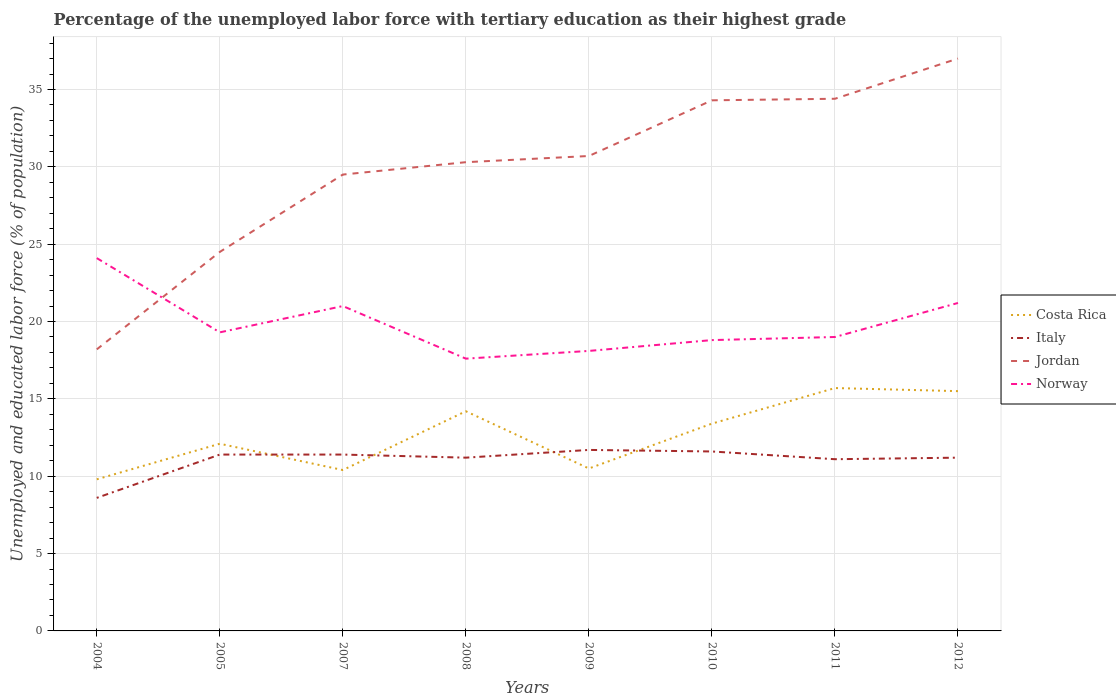Does the line corresponding to Costa Rica intersect with the line corresponding to Italy?
Your response must be concise. Yes. Is the number of lines equal to the number of legend labels?
Give a very brief answer. Yes. Across all years, what is the maximum percentage of the unemployed labor force with tertiary education in Italy?
Offer a very short reply. 8.6. In which year was the percentage of the unemployed labor force with tertiary education in Italy maximum?
Keep it short and to the point. 2004. What is the total percentage of the unemployed labor force with tertiary education in Jordan in the graph?
Your answer should be compact. -12.5. What is the difference between the highest and the second highest percentage of the unemployed labor force with tertiary education in Italy?
Offer a terse response. 3.1. What is the difference between the highest and the lowest percentage of the unemployed labor force with tertiary education in Jordan?
Keep it short and to the point. 5. How many lines are there?
Offer a terse response. 4. Where does the legend appear in the graph?
Your answer should be very brief. Center right. How are the legend labels stacked?
Make the answer very short. Vertical. What is the title of the graph?
Keep it short and to the point. Percentage of the unemployed labor force with tertiary education as their highest grade. What is the label or title of the X-axis?
Offer a very short reply. Years. What is the label or title of the Y-axis?
Provide a short and direct response. Unemployed and educated labor force (% of population). What is the Unemployed and educated labor force (% of population) of Costa Rica in 2004?
Your answer should be very brief. 9.8. What is the Unemployed and educated labor force (% of population) of Italy in 2004?
Keep it short and to the point. 8.6. What is the Unemployed and educated labor force (% of population) in Jordan in 2004?
Your answer should be very brief. 18.2. What is the Unemployed and educated labor force (% of population) of Norway in 2004?
Offer a terse response. 24.1. What is the Unemployed and educated labor force (% of population) in Costa Rica in 2005?
Offer a terse response. 12.1. What is the Unemployed and educated labor force (% of population) in Italy in 2005?
Keep it short and to the point. 11.4. What is the Unemployed and educated labor force (% of population) of Jordan in 2005?
Provide a succinct answer. 24.5. What is the Unemployed and educated labor force (% of population) in Norway in 2005?
Provide a short and direct response. 19.3. What is the Unemployed and educated labor force (% of population) of Costa Rica in 2007?
Ensure brevity in your answer.  10.4. What is the Unemployed and educated labor force (% of population) of Italy in 2007?
Your answer should be compact. 11.4. What is the Unemployed and educated labor force (% of population) in Jordan in 2007?
Your answer should be compact. 29.5. What is the Unemployed and educated labor force (% of population) in Costa Rica in 2008?
Provide a short and direct response. 14.2. What is the Unemployed and educated labor force (% of population) in Italy in 2008?
Your answer should be compact. 11.2. What is the Unemployed and educated labor force (% of population) in Jordan in 2008?
Ensure brevity in your answer.  30.3. What is the Unemployed and educated labor force (% of population) of Norway in 2008?
Your answer should be compact. 17.6. What is the Unemployed and educated labor force (% of population) of Costa Rica in 2009?
Keep it short and to the point. 10.5. What is the Unemployed and educated labor force (% of population) of Italy in 2009?
Make the answer very short. 11.7. What is the Unemployed and educated labor force (% of population) in Jordan in 2009?
Give a very brief answer. 30.7. What is the Unemployed and educated labor force (% of population) in Norway in 2009?
Your answer should be very brief. 18.1. What is the Unemployed and educated labor force (% of population) of Costa Rica in 2010?
Provide a succinct answer. 13.4. What is the Unemployed and educated labor force (% of population) in Italy in 2010?
Make the answer very short. 11.6. What is the Unemployed and educated labor force (% of population) in Jordan in 2010?
Provide a short and direct response. 34.3. What is the Unemployed and educated labor force (% of population) in Norway in 2010?
Provide a short and direct response. 18.8. What is the Unemployed and educated labor force (% of population) of Costa Rica in 2011?
Your answer should be very brief. 15.7. What is the Unemployed and educated labor force (% of population) in Italy in 2011?
Provide a short and direct response. 11.1. What is the Unemployed and educated labor force (% of population) of Jordan in 2011?
Your response must be concise. 34.4. What is the Unemployed and educated labor force (% of population) in Costa Rica in 2012?
Provide a short and direct response. 15.5. What is the Unemployed and educated labor force (% of population) in Italy in 2012?
Offer a terse response. 11.2. What is the Unemployed and educated labor force (% of population) of Norway in 2012?
Keep it short and to the point. 21.2. Across all years, what is the maximum Unemployed and educated labor force (% of population) of Costa Rica?
Provide a succinct answer. 15.7. Across all years, what is the maximum Unemployed and educated labor force (% of population) in Italy?
Give a very brief answer. 11.7. Across all years, what is the maximum Unemployed and educated labor force (% of population) of Jordan?
Give a very brief answer. 37. Across all years, what is the maximum Unemployed and educated labor force (% of population) in Norway?
Your answer should be very brief. 24.1. Across all years, what is the minimum Unemployed and educated labor force (% of population) of Costa Rica?
Provide a short and direct response. 9.8. Across all years, what is the minimum Unemployed and educated labor force (% of population) of Italy?
Provide a succinct answer. 8.6. Across all years, what is the minimum Unemployed and educated labor force (% of population) of Jordan?
Your response must be concise. 18.2. Across all years, what is the minimum Unemployed and educated labor force (% of population) of Norway?
Ensure brevity in your answer.  17.6. What is the total Unemployed and educated labor force (% of population) in Costa Rica in the graph?
Your response must be concise. 101.6. What is the total Unemployed and educated labor force (% of population) in Italy in the graph?
Make the answer very short. 88.2. What is the total Unemployed and educated labor force (% of population) in Jordan in the graph?
Give a very brief answer. 238.9. What is the total Unemployed and educated labor force (% of population) of Norway in the graph?
Keep it short and to the point. 159.1. What is the difference between the Unemployed and educated labor force (% of population) in Costa Rica in 2004 and that in 2005?
Give a very brief answer. -2.3. What is the difference between the Unemployed and educated labor force (% of population) of Jordan in 2004 and that in 2005?
Offer a very short reply. -6.3. What is the difference between the Unemployed and educated labor force (% of population) in Costa Rica in 2004 and that in 2007?
Ensure brevity in your answer.  -0.6. What is the difference between the Unemployed and educated labor force (% of population) of Italy in 2004 and that in 2007?
Your answer should be very brief. -2.8. What is the difference between the Unemployed and educated labor force (% of population) in Italy in 2004 and that in 2009?
Make the answer very short. -3.1. What is the difference between the Unemployed and educated labor force (% of population) in Jordan in 2004 and that in 2009?
Provide a succinct answer. -12.5. What is the difference between the Unemployed and educated labor force (% of population) of Norway in 2004 and that in 2009?
Offer a terse response. 6. What is the difference between the Unemployed and educated labor force (% of population) in Costa Rica in 2004 and that in 2010?
Keep it short and to the point. -3.6. What is the difference between the Unemployed and educated labor force (% of population) in Jordan in 2004 and that in 2010?
Give a very brief answer. -16.1. What is the difference between the Unemployed and educated labor force (% of population) in Italy in 2004 and that in 2011?
Ensure brevity in your answer.  -2.5. What is the difference between the Unemployed and educated labor force (% of population) in Jordan in 2004 and that in 2011?
Offer a terse response. -16.2. What is the difference between the Unemployed and educated labor force (% of population) in Norway in 2004 and that in 2011?
Your answer should be very brief. 5.1. What is the difference between the Unemployed and educated labor force (% of population) of Jordan in 2004 and that in 2012?
Offer a terse response. -18.8. What is the difference between the Unemployed and educated labor force (% of population) of Norway in 2004 and that in 2012?
Your answer should be compact. 2.9. What is the difference between the Unemployed and educated labor force (% of population) of Italy in 2005 and that in 2007?
Give a very brief answer. 0. What is the difference between the Unemployed and educated labor force (% of population) in Jordan in 2005 and that in 2007?
Your answer should be compact. -5. What is the difference between the Unemployed and educated labor force (% of population) in Norway in 2005 and that in 2007?
Ensure brevity in your answer.  -1.7. What is the difference between the Unemployed and educated labor force (% of population) of Italy in 2005 and that in 2008?
Keep it short and to the point. 0.2. What is the difference between the Unemployed and educated labor force (% of population) of Jordan in 2005 and that in 2008?
Keep it short and to the point. -5.8. What is the difference between the Unemployed and educated labor force (% of population) of Italy in 2005 and that in 2009?
Ensure brevity in your answer.  -0.3. What is the difference between the Unemployed and educated labor force (% of population) of Jordan in 2005 and that in 2009?
Your response must be concise. -6.2. What is the difference between the Unemployed and educated labor force (% of population) in Costa Rica in 2005 and that in 2010?
Keep it short and to the point. -1.3. What is the difference between the Unemployed and educated labor force (% of population) in Italy in 2005 and that in 2010?
Offer a terse response. -0.2. What is the difference between the Unemployed and educated labor force (% of population) of Jordan in 2005 and that in 2010?
Offer a very short reply. -9.8. What is the difference between the Unemployed and educated labor force (% of population) in Norway in 2005 and that in 2011?
Your answer should be very brief. 0.3. What is the difference between the Unemployed and educated labor force (% of population) in Italy in 2005 and that in 2012?
Your response must be concise. 0.2. What is the difference between the Unemployed and educated labor force (% of population) in Jordan in 2005 and that in 2012?
Your response must be concise. -12.5. What is the difference between the Unemployed and educated labor force (% of population) of Costa Rica in 2007 and that in 2008?
Ensure brevity in your answer.  -3.8. What is the difference between the Unemployed and educated labor force (% of population) in Italy in 2007 and that in 2009?
Ensure brevity in your answer.  -0.3. What is the difference between the Unemployed and educated labor force (% of population) in Jordan in 2007 and that in 2009?
Give a very brief answer. -1.2. What is the difference between the Unemployed and educated labor force (% of population) of Costa Rica in 2007 and that in 2010?
Provide a short and direct response. -3. What is the difference between the Unemployed and educated labor force (% of population) of Costa Rica in 2007 and that in 2011?
Keep it short and to the point. -5.3. What is the difference between the Unemployed and educated labor force (% of population) in Italy in 2007 and that in 2011?
Give a very brief answer. 0.3. What is the difference between the Unemployed and educated labor force (% of population) of Jordan in 2007 and that in 2011?
Your answer should be compact. -4.9. What is the difference between the Unemployed and educated labor force (% of population) in Italy in 2007 and that in 2012?
Provide a short and direct response. 0.2. What is the difference between the Unemployed and educated labor force (% of population) of Norway in 2007 and that in 2012?
Provide a succinct answer. -0.2. What is the difference between the Unemployed and educated labor force (% of population) of Costa Rica in 2008 and that in 2009?
Offer a terse response. 3.7. What is the difference between the Unemployed and educated labor force (% of population) of Norway in 2008 and that in 2009?
Provide a succinct answer. -0.5. What is the difference between the Unemployed and educated labor force (% of population) of Italy in 2008 and that in 2010?
Your response must be concise. -0.4. What is the difference between the Unemployed and educated labor force (% of population) in Norway in 2008 and that in 2010?
Give a very brief answer. -1.2. What is the difference between the Unemployed and educated labor force (% of population) in Jordan in 2008 and that in 2011?
Your answer should be compact. -4.1. What is the difference between the Unemployed and educated labor force (% of population) in Norway in 2008 and that in 2011?
Your answer should be very brief. -1.4. What is the difference between the Unemployed and educated labor force (% of population) of Costa Rica in 2008 and that in 2012?
Keep it short and to the point. -1.3. What is the difference between the Unemployed and educated labor force (% of population) in Italy in 2008 and that in 2012?
Your answer should be compact. 0. What is the difference between the Unemployed and educated labor force (% of population) in Jordan in 2008 and that in 2012?
Keep it short and to the point. -6.7. What is the difference between the Unemployed and educated labor force (% of population) of Norway in 2008 and that in 2012?
Offer a terse response. -3.6. What is the difference between the Unemployed and educated labor force (% of population) of Jordan in 2009 and that in 2010?
Offer a very short reply. -3.6. What is the difference between the Unemployed and educated labor force (% of population) in Italy in 2009 and that in 2011?
Keep it short and to the point. 0.6. What is the difference between the Unemployed and educated labor force (% of population) of Jordan in 2009 and that in 2011?
Give a very brief answer. -3.7. What is the difference between the Unemployed and educated labor force (% of population) of Italy in 2009 and that in 2012?
Offer a very short reply. 0.5. What is the difference between the Unemployed and educated labor force (% of population) in Jordan in 2010 and that in 2011?
Give a very brief answer. -0.1. What is the difference between the Unemployed and educated labor force (% of population) in Jordan in 2010 and that in 2012?
Make the answer very short. -2.7. What is the difference between the Unemployed and educated labor force (% of population) in Norway in 2010 and that in 2012?
Provide a succinct answer. -2.4. What is the difference between the Unemployed and educated labor force (% of population) of Costa Rica in 2011 and that in 2012?
Your response must be concise. 0.2. What is the difference between the Unemployed and educated labor force (% of population) of Italy in 2011 and that in 2012?
Ensure brevity in your answer.  -0.1. What is the difference between the Unemployed and educated labor force (% of population) in Costa Rica in 2004 and the Unemployed and educated labor force (% of population) in Italy in 2005?
Provide a succinct answer. -1.6. What is the difference between the Unemployed and educated labor force (% of population) of Costa Rica in 2004 and the Unemployed and educated labor force (% of population) of Jordan in 2005?
Your answer should be very brief. -14.7. What is the difference between the Unemployed and educated labor force (% of population) of Italy in 2004 and the Unemployed and educated labor force (% of population) of Jordan in 2005?
Your response must be concise. -15.9. What is the difference between the Unemployed and educated labor force (% of population) of Italy in 2004 and the Unemployed and educated labor force (% of population) of Norway in 2005?
Keep it short and to the point. -10.7. What is the difference between the Unemployed and educated labor force (% of population) of Costa Rica in 2004 and the Unemployed and educated labor force (% of population) of Italy in 2007?
Keep it short and to the point. -1.6. What is the difference between the Unemployed and educated labor force (% of population) in Costa Rica in 2004 and the Unemployed and educated labor force (% of population) in Jordan in 2007?
Give a very brief answer. -19.7. What is the difference between the Unemployed and educated labor force (% of population) in Italy in 2004 and the Unemployed and educated labor force (% of population) in Jordan in 2007?
Your answer should be compact. -20.9. What is the difference between the Unemployed and educated labor force (% of population) of Jordan in 2004 and the Unemployed and educated labor force (% of population) of Norway in 2007?
Your response must be concise. -2.8. What is the difference between the Unemployed and educated labor force (% of population) in Costa Rica in 2004 and the Unemployed and educated labor force (% of population) in Italy in 2008?
Give a very brief answer. -1.4. What is the difference between the Unemployed and educated labor force (% of population) in Costa Rica in 2004 and the Unemployed and educated labor force (% of population) in Jordan in 2008?
Give a very brief answer. -20.5. What is the difference between the Unemployed and educated labor force (% of population) in Costa Rica in 2004 and the Unemployed and educated labor force (% of population) in Norway in 2008?
Offer a terse response. -7.8. What is the difference between the Unemployed and educated labor force (% of population) of Italy in 2004 and the Unemployed and educated labor force (% of population) of Jordan in 2008?
Provide a succinct answer. -21.7. What is the difference between the Unemployed and educated labor force (% of population) in Costa Rica in 2004 and the Unemployed and educated labor force (% of population) in Italy in 2009?
Offer a very short reply. -1.9. What is the difference between the Unemployed and educated labor force (% of population) in Costa Rica in 2004 and the Unemployed and educated labor force (% of population) in Jordan in 2009?
Keep it short and to the point. -20.9. What is the difference between the Unemployed and educated labor force (% of population) in Costa Rica in 2004 and the Unemployed and educated labor force (% of population) in Norway in 2009?
Give a very brief answer. -8.3. What is the difference between the Unemployed and educated labor force (% of population) in Italy in 2004 and the Unemployed and educated labor force (% of population) in Jordan in 2009?
Provide a succinct answer. -22.1. What is the difference between the Unemployed and educated labor force (% of population) of Italy in 2004 and the Unemployed and educated labor force (% of population) of Norway in 2009?
Offer a terse response. -9.5. What is the difference between the Unemployed and educated labor force (% of population) in Costa Rica in 2004 and the Unemployed and educated labor force (% of population) in Italy in 2010?
Provide a short and direct response. -1.8. What is the difference between the Unemployed and educated labor force (% of population) in Costa Rica in 2004 and the Unemployed and educated labor force (% of population) in Jordan in 2010?
Ensure brevity in your answer.  -24.5. What is the difference between the Unemployed and educated labor force (% of population) in Costa Rica in 2004 and the Unemployed and educated labor force (% of population) in Norway in 2010?
Your answer should be very brief. -9. What is the difference between the Unemployed and educated labor force (% of population) in Italy in 2004 and the Unemployed and educated labor force (% of population) in Jordan in 2010?
Offer a very short reply. -25.7. What is the difference between the Unemployed and educated labor force (% of population) in Italy in 2004 and the Unemployed and educated labor force (% of population) in Norway in 2010?
Give a very brief answer. -10.2. What is the difference between the Unemployed and educated labor force (% of population) in Jordan in 2004 and the Unemployed and educated labor force (% of population) in Norway in 2010?
Give a very brief answer. -0.6. What is the difference between the Unemployed and educated labor force (% of population) in Costa Rica in 2004 and the Unemployed and educated labor force (% of population) in Jordan in 2011?
Offer a very short reply. -24.6. What is the difference between the Unemployed and educated labor force (% of population) in Italy in 2004 and the Unemployed and educated labor force (% of population) in Jordan in 2011?
Your answer should be compact. -25.8. What is the difference between the Unemployed and educated labor force (% of population) in Italy in 2004 and the Unemployed and educated labor force (% of population) in Norway in 2011?
Keep it short and to the point. -10.4. What is the difference between the Unemployed and educated labor force (% of population) in Costa Rica in 2004 and the Unemployed and educated labor force (% of population) in Italy in 2012?
Your response must be concise. -1.4. What is the difference between the Unemployed and educated labor force (% of population) of Costa Rica in 2004 and the Unemployed and educated labor force (% of population) of Jordan in 2012?
Keep it short and to the point. -27.2. What is the difference between the Unemployed and educated labor force (% of population) of Costa Rica in 2004 and the Unemployed and educated labor force (% of population) of Norway in 2012?
Your response must be concise. -11.4. What is the difference between the Unemployed and educated labor force (% of population) of Italy in 2004 and the Unemployed and educated labor force (% of population) of Jordan in 2012?
Provide a succinct answer. -28.4. What is the difference between the Unemployed and educated labor force (% of population) in Italy in 2004 and the Unemployed and educated labor force (% of population) in Norway in 2012?
Offer a very short reply. -12.6. What is the difference between the Unemployed and educated labor force (% of population) in Jordan in 2004 and the Unemployed and educated labor force (% of population) in Norway in 2012?
Offer a terse response. -3. What is the difference between the Unemployed and educated labor force (% of population) of Costa Rica in 2005 and the Unemployed and educated labor force (% of population) of Jordan in 2007?
Provide a succinct answer. -17.4. What is the difference between the Unemployed and educated labor force (% of population) in Italy in 2005 and the Unemployed and educated labor force (% of population) in Jordan in 2007?
Keep it short and to the point. -18.1. What is the difference between the Unemployed and educated labor force (% of population) of Italy in 2005 and the Unemployed and educated labor force (% of population) of Norway in 2007?
Provide a short and direct response. -9.6. What is the difference between the Unemployed and educated labor force (% of population) in Jordan in 2005 and the Unemployed and educated labor force (% of population) in Norway in 2007?
Offer a terse response. 3.5. What is the difference between the Unemployed and educated labor force (% of population) in Costa Rica in 2005 and the Unemployed and educated labor force (% of population) in Jordan in 2008?
Provide a succinct answer. -18.2. What is the difference between the Unemployed and educated labor force (% of population) of Costa Rica in 2005 and the Unemployed and educated labor force (% of population) of Norway in 2008?
Offer a terse response. -5.5. What is the difference between the Unemployed and educated labor force (% of population) of Italy in 2005 and the Unemployed and educated labor force (% of population) of Jordan in 2008?
Give a very brief answer. -18.9. What is the difference between the Unemployed and educated labor force (% of population) of Italy in 2005 and the Unemployed and educated labor force (% of population) of Norway in 2008?
Keep it short and to the point. -6.2. What is the difference between the Unemployed and educated labor force (% of population) in Costa Rica in 2005 and the Unemployed and educated labor force (% of population) in Jordan in 2009?
Your response must be concise. -18.6. What is the difference between the Unemployed and educated labor force (% of population) in Costa Rica in 2005 and the Unemployed and educated labor force (% of population) in Norway in 2009?
Make the answer very short. -6. What is the difference between the Unemployed and educated labor force (% of population) of Italy in 2005 and the Unemployed and educated labor force (% of population) of Jordan in 2009?
Provide a succinct answer. -19.3. What is the difference between the Unemployed and educated labor force (% of population) of Costa Rica in 2005 and the Unemployed and educated labor force (% of population) of Jordan in 2010?
Give a very brief answer. -22.2. What is the difference between the Unemployed and educated labor force (% of population) of Italy in 2005 and the Unemployed and educated labor force (% of population) of Jordan in 2010?
Keep it short and to the point. -22.9. What is the difference between the Unemployed and educated labor force (% of population) in Italy in 2005 and the Unemployed and educated labor force (% of population) in Norway in 2010?
Make the answer very short. -7.4. What is the difference between the Unemployed and educated labor force (% of population) of Jordan in 2005 and the Unemployed and educated labor force (% of population) of Norway in 2010?
Provide a succinct answer. 5.7. What is the difference between the Unemployed and educated labor force (% of population) in Costa Rica in 2005 and the Unemployed and educated labor force (% of population) in Italy in 2011?
Ensure brevity in your answer.  1. What is the difference between the Unemployed and educated labor force (% of population) of Costa Rica in 2005 and the Unemployed and educated labor force (% of population) of Jordan in 2011?
Give a very brief answer. -22.3. What is the difference between the Unemployed and educated labor force (% of population) in Costa Rica in 2005 and the Unemployed and educated labor force (% of population) in Norway in 2011?
Make the answer very short. -6.9. What is the difference between the Unemployed and educated labor force (% of population) in Italy in 2005 and the Unemployed and educated labor force (% of population) in Jordan in 2011?
Offer a very short reply. -23. What is the difference between the Unemployed and educated labor force (% of population) in Italy in 2005 and the Unemployed and educated labor force (% of population) in Norway in 2011?
Your response must be concise. -7.6. What is the difference between the Unemployed and educated labor force (% of population) in Costa Rica in 2005 and the Unemployed and educated labor force (% of population) in Italy in 2012?
Offer a terse response. 0.9. What is the difference between the Unemployed and educated labor force (% of population) in Costa Rica in 2005 and the Unemployed and educated labor force (% of population) in Jordan in 2012?
Your answer should be very brief. -24.9. What is the difference between the Unemployed and educated labor force (% of population) of Italy in 2005 and the Unemployed and educated labor force (% of population) of Jordan in 2012?
Your response must be concise. -25.6. What is the difference between the Unemployed and educated labor force (% of population) in Costa Rica in 2007 and the Unemployed and educated labor force (% of population) in Jordan in 2008?
Your response must be concise. -19.9. What is the difference between the Unemployed and educated labor force (% of population) of Costa Rica in 2007 and the Unemployed and educated labor force (% of population) of Norway in 2008?
Offer a terse response. -7.2. What is the difference between the Unemployed and educated labor force (% of population) of Italy in 2007 and the Unemployed and educated labor force (% of population) of Jordan in 2008?
Give a very brief answer. -18.9. What is the difference between the Unemployed and educated labor force (% of population) of Italy in 2007 and the Unemployed and educated labor force (% of population) of Norway in 2008?
Your answer should be compact. -6.2. What is the difference between the Unemployed and educated labor force (% of population) in Jordan in 2007 and the Unemployed and educated labor force (% of population) in Norway in 2008?
Keep it short and to the point. 11.9. What is the difference between the Unemployed and educated labor force (% of population) of Costa Rica in 2007 and the Unemployed and educated labor force (% of population) of Italy in 2009?
Offer a terse response. -1.3. What is the difference between the Unemployed and educated labor force (% of population) in Costa Rica in 2007 and the Unemployed and educated labor force (% of population) in Jordan in 2009?
Ensure brevity in your answer.  -20.3. What is the difference between the Unemployed and educated labor force (% of population) in Italy in 2007 and the Unemployed and educated labor force (% of population) in Jordan in 2009?
Keep it short and to the point. -19.3. What is the difference between the Unemployed and educated labor force (% of population) of Italy in 2007 and the Unemployed and educated labor force (% of population) of Norway in 2009?
Offer a very short reply. -6.7. What is the difference between the Unemployed and educated labor force (% of population) in Jordan in 2007 and the Unemployed and educated labor force (% of population) in Norway in 2009?
Offer a very short reply. 11.4. What is the difference between the Unemployed and educated labor force (% of population) in Costa Rica in 2007 and the Unemployed and educated labor force (% of population) in Italy in 2010?
Your answer should be compact. -1.2. What is the difference between the Unemployed and educated labor force (% of population) in Costa Rica in 2007 and the Unemployed and educated labor force (% of population) in Jordan in 2010?
Your answer should be very brief. -23.9. What is the difference between the Unemployed and educated labor force (% of population) in Italy in 2007 and the Unemployed and educated labor force (% of population) in Jordan in 2010?
Offer a very short reply. -22.9. What is the difference between the Unemployed and educated labor force (% of population) in Italy in 2007 and the Unemployed and educated labor force (% of population) in Norway in 2010?
Keep it short and to the point. -7.4. What is the difference between the Unemployed and educated labor force (% of population) in Jordan in 2007 and the Unemployed and educated labor force (% of population) in Norway in 2010?
Your answer should be very brief. 10.7. What is the difference between the Unemployed and educated labor force (% of population) in Costa Rica in 2007 and the Unemployed and educated labor force (% of population) in Italy in 2011?
Make the answer very short. -0.7. What is the difference between the Unemployed and educated labor force (% of population) of Costa Rica in 2007 and the Unemployed and educated labor force (% of population) of Norway in 2011?
Your answer should be very brief. -8.6. What is the difference between the Unemployed and educated labor force (% of population) of Jordan in 2007 and the Unemployed and educated labor force (% of population) of Norway in 2011?
Your answer should be very brief. 10.5. What is the difference between the Unemployed and educated labor force (% of population) of Costa Rica in 2007 and the Unemployed and educated labor force (% of population) of Italy in 2012?
Keep it short and to the point. -0.8. What is the difference between the Unemployed and educated labor force (% of population) of Costa Rica in 2007 and the Unemployed and educated labor force (% of population) of Jordan in 2012?
Offer a terse response. -26.6. What is the difference between the Unemployed and educated labor force (% of population) of Costa Rica in 2007 and the Unemployed and educated labor force (% of population) of Norway in 2012?
Keep it short and to the point. -10.8. What is the difference between the Unemployed and educated labor force (% of population) in Italy in 2007 and the Unemployed and educated labor force (% of population) in Jordan in 2012?
Make the answer very short. -25.6. What is the difference between the Unemployed and educated labor force (% of population) of Italy in 2007 and the Unemployed and educated labor force (% of population) of Norway in 2012?
Offer a terse response. -9.8. What is the difference between the Unemployed and educated labor force (% of population) of Jordan in 2007 and the Unemployed and educated labor force (% of population) of Norway in 2012?
Keep it short and to the point. 8.3. What is the difference between the Unemployed and educated labor force (% of population) in Costa Rica in 2008 and the Unemployed and educated labor force (% of population) in Jordan in 2009?
Your response must be concise. -16.5. What is the difference between the Unemployed and educated labor force (% of population) of Costa Rica in 2008 and the Unemployed and educated labor force (% of population) of Norway in 2009?
Provide a succinct answer. -3.9. What is the difference between the Unemployed and educated labor force (% of population) of Italy in 2008 and the Unemployed and educated labor force (% of population) of Jordan in 2009?
Your answer should be very brief. -19.5. What is the difference between the Unemployed and educated labor force (% of population) in Costa Rica in 2008 and the Unemployed and educated labor force (% of population) in Italy in 2010?
Provide a succinct answer. 2.6. What is the difference between the Unemployed and educated labor force (% of population) in Costa Rica in 2008 and the Unemployed and educated labor force (% of population) in Jordan in 2010?
Keep it short and to the point. -20.1. What is the difference between the Unemployed and educated labor force (% of population) of Italy in 2008 and the Unemployed and educated labor force (% of population) of Jordan in 2010?
Your response must be concise. -23.1. What is the difference between the Unemployed and educated labor force (% of population) of Italy in 2008 and the Unemployed and educated labor force (% of population) of Norway in 2010?
Provide a succinct answer. -7.6. What is the difference between the Unemployed and educated labor force (% of population) of Jordan in 2008 and the Unemployed and educated labor force (% of population) of Norway in 2010?
Your answer should be compact. 11.5. What is the difference between the Unemployed and educated labor force (% of population) in Costa Rica in 2008 and the Unemployed and educated labor force (% of population) in Jordan in 2011?
Provide a succinct answer. -20.2. What is the difference between the Unemployed and educated labor force (% of population) of Italy in 2008 and the Unemployed and educated labor force (% of population) of Jordan in 2011?
Your response must be concise. -23.2. What is the difference between the Unemployed and educated labor force (% of population) of Italy in 2008 and the Unemployed and educated labor force (% of population) of Norway in 2011?
Offer a terse response. -7.8. What is the difference between the Unemployed and educated labor force (% of population) in Costa Rica in 2008 and the Unemployed and educated labor force (% of population) in Jordan in 2012?
Your answer should be compact. -22.8. What is the difference between the Unemployed and educated labor force (% of population) of Italy in 2008 and the Unemployed and educated labor force (% of population) of Jordan in 2012?
Keep it short and to the point. -25.8. What is the difference between the Unemployed and educated labor force (% of population) in Italy in 2008 and the Unemployed and educated labor force (% of population) in Norway in 2012?
Your answer should be very brief. -10. What is the difference between the Unemployed and educated labor force (% of population) of Costa Rica in 2009 and the Unemployed and educated labor force (% of population) of Jordan in 2010?
Make the answer very short. -23.8. What is the difference between the Unemployed and educated labor force (% of population) of Costa Rica in 2009 and the Unemployed and educated labor force (% of population) of Norway in 2010?
Offer a terse response. -8.3. What is the difference between the Unemployed and educated labor force (% of population) in Italy in 2009 and the Unemployed and educated labor force (% of population) in Jordan in 2010?
Your answer should be very brief. -22.6. What is the difference between the Unemployed and educated labor force (% of population) of Costa Rica in 2009 and the Unemployed and educated labor force (% of population) of Jordan in 2011?
Keep it short and to the point. -23.9. What is the difference between the Unemployed and educated labor force (% of population) in Italy in 2009 and the Unemployed and educated labor force (% of population) in Jordan in 2011?
Provide a succinct answer. -22.7. What is the difference between the Unemployed and educated labor force (% of population) of Italy in 2009 and the Unemployed and educated labor force (% of population) of Norway in 2011?
Your answer should be compact. -7.3. What is the difference between the Unemployed and educated labor force (% of population) in Jordan in 2009 and the Unemployed and educated labor force (% of population) in Norway in 2011?
Keep it short and to the point. 11.7. What is the difference between the Unemployed and educated labor force (% of population) in Costa Rica in 2009 and the Unemployed and educated labor force (% of population) in Jordan in 2012?
Ensure brevity in your answer.  -26.5. What is the difference between the Unemployed and educated labor force (% of population) in Italy in 2009 and the Unemployed and educated labor force (% of population) in Jordan in 2012?
Offer a very short reply. -25.3. What is the difference between the Unemployed and educated labor force (% of population) of Italy in 2009 and the Unemployed and educated labor force (% of population) of Norway in 2012?
Offer a terse response. -9.5. What is the difference between the Unemployed and educated labor force (% of population) in Costa Rica in 2010 and the Unemployed and educated labor force (% of population) in Jordan in 2011?
Provide a short and direct response. -21. What is the difference between the Unemployed and educated labor force (% of population) of Italy in 2010 and the Unemployed and educated labor force (% of population) of Jordan in 2011?
Your answer should be very brief. -22.8. What is the difference between the Unemployed and educated labor force (% of population) of Costa Rica in 2010 and the Unemployed and educated labor force (% of population) of Jordan in 2012?
Offer a very short reply. -23.6. What is the difference between the Unemployed and educated labor force (% of population) of Italy in 2010 and the Unemployed and educated labor force (% of population) of Jordan in 2012?
Provide a succinct answer. -25.4. What is the difference between the Unemployed and educated labor force (% of population) of Italy in 2010 and the Unemployed and educated labor force (% of population) of Norway in 2012?
Keep it short and to the point. -9.6. What is the difference between the Unemployed and educated labor force (% of population) in Jordan in 2010 and the Unemployed and educated labor force (% of population) in Norway in 2012?
Make the answer very short. 13.1. What is the difference between the Unemployed and educated labor force (% of population) in Costa Rica in 2011 and the Unemployed and educated labor force (% of population) in Jordan in 2012?
Your response must be concise. -21.3. What is the difference between the Unemployed and educated labor force (% of population) in Costa Rica in 2011 and the Unemployed and educated labor force (% of population) in Norway in 2012?
Your answer should be compact. -5.5. What is the difference between the Unemployed and educated labor force (% of population) of Italy in 2011 and the Unemployed and educated labor force (% of population) of Jordan in 2012?
Your answer should be very brief. -25.9. What is the difference between the Unemployed and educated labor force (% of population) of Italy in 2011 and the Unemployed and educated labor force (% of population) of Norway in 2012?
Keep it short and to the point. -10.1. What is the difference between the Unemployed and educated labor force (% of population) in Jordan in 2011 and the Unemployed and educated labor force (% of population) in Norway in 2012?
Your answer should be very brief. 13.2. What is the average Unemployed and educated labor force (% of population) of Costa Rica per year?
Your answer should be very brief. 12.7. What is the average Unemployed and educated labor force (% of population) of Italy per year?
Your answer should be compact. 11.03. What is the average Unemployed and educated labor force (% of population) in Jordan per year?
Make the answer very short. 29.86. What is the average Unemployed and educated labor force (% of population) of Norway per year?
Offer a very short reply. 19.89. In the year 2004, what is the difference between the Unemployed and educated labor force (% of population) of Costa Rica and Unemployed and educated labor force (% of population) of Italy?
Ensure brevity in your answer.  1.2. In the year 2004, what is the difference between the Unemployed and educated labor force (% of population) of Costa Rica and Unemployed and educated labor force (% of population) of Jordan?
Provide a succinct answer. -8.4. In the year 2004, what is the difference between the Unemployed and educated labor force (% of population) of Costa Rica and Unemployed and educated labor force (% of population) of Norway?
Provide a succinct answer. -14.3. In the year 2004, what is the difference between the Unemployed and educated labor force (% of population) in Italy and Unemployed and educated labor force (% of population) in Jordan?
Ensure brevity in your answer.  -9.6. In the year 2004, what is the difference between the Unemployed and educated labor force (% of population) in Italy and Unemployed and educated labor force (% of population) in Norway?
Keep it short and to the point. -15.5. In the year 2005, what is the difference between the Unemployed and educated labor force (% of population) in Costa Rica and Unemployed and educated labor force (% of population) in Italy?
Keep it short and to the point. 0.7. In the year 2005, what is the difference between the Unemployed and educated labor force (% of population) of Costa Rica and Unemployed and educated labor force (% of population) of Jordan?
Your response must be concise. -12.4. In the year 2007, what is the difference between the Unemployed and educated labor force (% of population) of Costa Rica and Unemployed and educated labor force (% of population) of Italy?
Your answer should be very brief. -1. In the year 2007, what is the difference between the Unemployed and educated labor force (% of population) of Costa Rica and Unemployed and educated labor force (% of population) of Jordan?
Make the answer very short. -19.1. In the year 2007, what is the difference between the Unemployed and educated labor force (% of population) of Costa Rica and Unemployed and educated labor force (% of population) of Norway?
Provide a succinct answer. -10.6. In the year 2007, what is the difference between the Unemployed and educated labor force (% of population) in Italy and Unemployed and educated labor force (% of population) in Jordan?
Provide a succinct answer. -18.1. In the year 2007, what is the difference between the Unemployed and educated labor force (% of population) in Italy and Unemployed and educated labor force (% of population) in Norway?
Provide a succinct answer. -9.6. In the year 2008, what is the difference between the Unemployed and educated labor force (% of population) in Costa Rica and Unemployed and educated labor force (% of population) in Jordan?
Provide a short and direct response. -16.1. In the year 2008, what is the difference between the Unemployed and educated labor force (% of population) of Italy and Unemployed and educated labor force (% of population) of Jordan?
Your answer should be compact. -19.1. In the year 2009, what is the difference between the Unemployed and educated labor force (% of population) of Costa Rica and Unemployed and educated labor force (% of population) of Jordan?
Keep it short and to the point. -20.2. In the year 2009, what is the difference between the Unemployed and educated labor force (% of population) of Costa Rica and Unemployed and educated labor force (% of population) of Norway?
Provide a short and direct response. -7.6. In the year 2009, what is the difference between the Unemployed and educated labor force (% of population) in Italy and Unemployed and educated labor force (% of population) in Jordan?
Provide a succinct answer. -19. In the year 2009, what is the difference between the Unemployed and educated labor force (% of population) in Jordan and Unemployed and educated labor force (% of population) in Norway?
Offer a very short reply. 12.6. In the year 2010, what is the difference between the Unemployed and educated labor force (% of population) of Costa Rica and Unemployed and educated labor force (% of population) of Italy?
Keep it short and to the point. 1.8. In the year 2010, what is the difference between the Unemployed and educated labor force (% of population) of Costa Rica and Unemployed and educated labor force (% of population) of Jordan?
Provide a short and direct response. -20.9. In the year 2010, what is the difference between the Unemployed and educated labor force (% of population) in Costa Rica and Unemployed and educated labor force (% of population) in Norway?
Ensure brevity in your answer.  -5.4. In the year 2010, what is the difference between the Unemployed and educated labor force (% of population) in Italy and Unemployed and educated labor force (% of population) in Jordan?
Your response must be concise. -22.7. In the year 2010, what is the difference between the Unemployed and educated labor force (% of population) of Italy and Unemployed and educated labor force (% of population) of Norway?
Give a very brief answer. -7.2. In the year 2010, what is the difference between the Unemployed and educated labor force (% of population) of Jordan and Unemployed and educated labor force (% of population) of Norway?
Offer a very short reply. 15.5. In the year 2011, what is the difference between the Unemployed and educated labor force (% of population) of Costa Rica and Unemployed and educated labor force (% of population) of Italy?
Offer a very short reply. 4.6. In the year 2011, what is the difference between the Unemployed and educated labor force (% of population) of Costa Rica and Unemployed and educated labor force (% of population) of Jordan?
Offer a very short reply. -18.7. In the year 2011, what is the difference between the Unemployed and educated labor force (% of population) in Italy and Unemployed and educated labor force (% of population) in Jordan?
Offer a very short reply. -23.3. In the year 2011, what is the difference between the Unemployed and educated labor force (% of population) of Italy and Unemployed and educated labor force (% of population) of Norway?
Provide a succinct answer. -7.9. In the year 2011, what is the difference between the Unemployed and educated labor force (% of population) in Jordan and Unemployed and educated labor force (% of population) in Norway?
Keep it short and to the point. 15.4. In the year 2012, what is the difference between the Unemployed and educated labor force (% of population) in Costa Rica and Unemployed and educated labor force (% of population) in Italy?
Keep it short and to the point. 4.3. In the year 2012, what is the difference between the Unemployed and educated labor force (% of population) of Costa Rica and Unemployed and educated labor force (% of population) of Jordan?
Provide a short and direct response. -21.5. In the year 2012, what is the difference between the Unemployed and educated labor force (% of population) in Italy and Unemployed and educated labor force (% of population) in Jordan?
Give a very brief answer. -25.8. In the year 2012, what is the difference between the Unemployed and educated labor force (% of population) in Jordan and Unemployed and educated labor force (% of population) in Norway?
Offer a terse response. 15.8. What is the ratio of the Unemployed and educated labor force (% of population) in Costa Rica in 2004 to that in 2005?
Give a very brief answer. 0.81. What is the ratio of the Unemployed and educated labor force (% of population) of Italy in 2004 to that in 2005?
Provide a succinct answer. 0.75. What is the ratio of the Unemployed and educated labor force (% of population) of Jordan in 2004 to that in 2005?
Your answer should be very brief. 0.74. What is the ratio of the Unemployed and educated labor force (% of population) in Norway in 2004 to that in 2005?
Ensure brevity in your answer.  1.25. What is the ratio of the Unemployed and educated labor force (% of population) of Costa Rica in 2004 to that in 2007?
Ensure brevity in your answer.  0.94. What is the ratio of the Unemployed and educated labor force (% of population) of Italy in 2004 to that in 2007?
Your answer should be very brief. 0.75. What is the ratio of the Unemployed and educated labor force (% of population) in Jordan in 2004 to that in 2007?
Your response must be concise. 0.62. What is the ratio of the Unemployed and educated labor force (% of population) of Norway in 2004 to that in 2007?
Your response must be concise. 1.15. What is the ratio of the Unemployed and educated labor force (% of population) in Costa Rica in 2004 to that in 2008?
Your answer should be very brief. 0.69. What is the ratio of the Unemployed and educated labor force (% of population) in Italy in 2004 to that in 2008?
Provide a short and direct response. 0.77. What is the ratio of the Unemployed and educated labor force (% of population) of Jordan in 2004 to that in 2008?
Keep it short and to the point. 0.6. What is the ratio of the Unemployed and educated labor force (% of population) of Norway in 2004 to that in 2008?
Your answer should be very brief. 1.37. What is the ratio of the Unemployed and educated labor force (% of population) in Italy in 2004 to that in 2009?
Your response must be concise. 0.73. What is the ratio of the Unemployed and educated labor force (% of population) of Jordan in 2004 to that in 2009?
Offer a very short reply. 0.59. What is the ratio of the Unemployed and educated labor force (% of population) of Norway in 2004 to that in 2009?
Offer a very short reply. 1.33. What is the ratio of the Unemployed and educated labor force (% of population) in Costa Rica in 2004 to that in 2010?
Your answer should be very brief. 0.73. What is the ratio of the Unemployed and educated labor force (% of population) of Italy in 2004 to that in 2010?
Your response must be concise. 0.74. What is the ratio of the Unemployed and educated labor force (% of population) in Jordan in 2004 to that in 2010?
Provide a succinct answer. 0.53. What is the ratio of the Unemployed and educated labor force (% of population) of Norway in 2004 to that in 2010?
Make the answer very short. 1.28. What is the ratio of the Unemployed and educated labor force (% of population) in Costa Rica in 2004 to that in 2011?
Your response must be concise. 0.62. What is the ratio of the Unemployed and educated labor force (% of population) in Italy in 2004 to that in 2011?
Your answer should be very brief. 0.77. What is the ratio of the Unemployed and educated labor force (% of population) of Jordan in 2004 to that in 2011?
Provide a succinct answer. 0.53. What is the ratio of the Unemployed and educated labor force (% of population) in Norway in 2004 to that in 2011?
Your answer should be very brief. 1.27. What is the ratio of the Unemployed and educated labor force (% of population) of Costa Rica in 2004 to that in 2012?
Your answer should be compact. 0.63. What is the ratio of the Unemployed and educated labor force (% of population) of Italy in 2004 to that in 2012?
Ensure brevity in your answer.  0.77. What is the ratio of the Unemployed and educated labor force (% of population) of Jordan in 2004 to that in 2012?
Offer a terse response. 0.49. What is the ratio of the Unemployed and educated labor force (% of population) in Norway in 2004 to that in 2012?
Make the answer very short. 1.14. What is the ratio of the Unemployed and educated labor force (% of population) in Costa Rica in 2005 to that in 2007?
Keep it short and to the point. 1.16. What is the ratio of the Unemployed and educated labor force (% of population) of Jordan in 2005 to that in 2007?
Give a very brief answer. 0.83. What is the ratio of the Unemployed and educated labor force (% of population) of Norway in 2005 to that in 2007?
Offer a very short reply. 0.92. What is the ratio of the Unemployed and educated labor force (% of population) of Costa Rica in 2005 to that in 2008?
Your answer should be compact. 0.85. What is the ratio of the Unemployed and educated labor force (% of population) in Italy in 2005 to that in 2008?
Your answer should be very brief. 1.02. What is the ratio of the Unemployed and educated labor force (% of population) of Jordan in 2005 to that in 2008?
Ensure brevity in your answer.  0.81. What is the ratio of the Unemployed and educated labor force (% of population) of Norway in 2005 to that in 2008?
Give a very brief answer. 1.1. What is the ratio of the Unemployed and educated labor force (% of population) in Costa Rica in 2005 to that in 2009?
Your answer should be compact. 1.15. What is the ratio of the Unemployed and educated labor force (% of population) of Italy in 2005 to that in 2009?
Ensure brevity in your answer.  0.97. What is the ratio of the Unemployed and educated labor force (% of population) of Jordan in 2005 to that in 2009?
Offer a terse response. 0.8. What is the ratio of the Unemployed and educated labor force (% of population) in Norway in 2005 to that in 2009?
Offer a terse response. 1.07. What is the ratio of the Unemployed and educated labor force (% of population) of Costa Rica in 2005 to that in 2010?
Provide a succinct answer. 0.9. What is the ratio of the Unemployed and educated labor force (% of population) in Italy in 2005 to that in 2010?
Your answer should be compact. 0.98. What is the ratio of the Unemployed and educated labor force (% of population) of Norway in 2005 to that in 2010?
Ensure brevity in your answer.  1.03. What is the ratio of the Unemployed and educated labor force (% of population) of Costa Rica in 2005 to that in 2011?
Make the answer very short. 0.77. What is the ratio of the Unemployed and educated labor force (% of population) of Jordan in 2005 to that in 2011?
Your response must be concise. 0.71. What is the ratio of the Unemployed and educated labor force (% of population) in Norway in 2005 to that in 2011?
Provide a succinct answer. 1.02. What is the ratio of the Unemployed and educated labor force (% of population) of Costa Rica in 2005 to that in 2012?
Provide a succinct answer. 0.78. What is the ratio of the Unemployed and educated labor force (% of population) of Italy in 2005 to that in 2012?
Give a very brief answer. 1.02. What is the ratio of the Unemployed and educated labor force (% of population) of Jordan in 2005 to that in 2012?
Keep it short and to the point. 0.66. What is the ratio of the Unemployed and educated labor force (% of population) in Norway in 2005 to that in 2012?
Make the answer very short. 0.91. What is the ratio of the Unemployed and educated labor force (% of population) of Costa Rica in 2007 to that in 2008?
Your answer should be compact. 0.73. What is the ratio of the Unemployed and educated labor force (% of population) of Italy in 2007 to that in 2008?
Provide a short and direct response. 1.02. What is the ratio of the Unemployed and educated labor force (% of population) of Jordan in 2007 to that in 2008?
Provide a short and direct response. 0.97. What is the ratio of the Unemployed and educated labor force (% of population) in Norway in 2007 to that in 2008?
Give a very brief answer. 1.19. What is the ratio of the Unemployed and educated labor force (% of population) of Costa Rica in 2007 to that in 2009?
Ensure brevity in your answer.  0.99. What is the ratio of the Unemployed and educated labor force (% of population) in Italy in 2007 to that in 2009?
Ensure brevity in your answer.  0.97. What is the ratio of the Unemployed and educated labor force (% of population) in Jordan in 2007 to that in 2009?
Ensure brevity in your answer.  0.96. What is the ratio of the Unemployed and educated labor force (% of population) in Norway in 2007 to that in 2009?
Your response must be concise. 1.16. What is the ratio of the Unemployed and educated labor force (% of population) of Costa Rica in 2007 to that in 2010?
Provide a succinct answer. 0.78. What is the ratio of the Unemployed and educated labor force (% of population) of Italy in 2007 to that in 2010?
Offer a terse response. 0.98. What is the ratio of the Unemployed and educated labor force (% of population) of Jordan in 2007 to that in 2010?
Your response must be concise. 0.86. What is the ratio of the Unemployed and educated labor force (% of population) in Norway in 2007 to that in 2010?
Keep it short and to the point. 1.12. What is the ratio of the Unemployed and educated labor force (% of population) of Costa Rica in 2007 to that in 2011?
Your response must be concise. 0.66. What is the ratio of the Unemployed and educated labor force (% of population) in Jordan in 2007 to that in 2011?
Give a very brief answer. 0.86. What is the ratio of the Unemployed and educated labor force (% of population) of Norway in 2007 to that in 2011?
Your answer should be very brief. 1.11. What is the ratio of the Unemployed and educated labor force (% of population) of Costa Rica in 2007 to that in 2012?
Keep it short and to the point. 0.67. What is the ratio of the Unemployed and educated labor force (% of population) of Italy in 2007 to that in 2012?
Your answer should be very brief. 1.02. What is the ratio of the Unemployed and educated labor force (% of population) of Jordan in 2007 to that in 2012?
Give a very brief answer. 0.8. What is the ratio of the Unemployed and educated labor force (% of population) of Norway in 2007 to that in 2012?
Make the answer very short. 0.99. What is the ratio of the Unemployed and educated labor force (% of population) of Costa Rica in 2008 to that in 2009?
Make the answer very short. 1.35. What is the ratio of the Unemployed and educated labor force (% of population) of Italy in 2008 to that in 2009?
Keep it short and to the point. 0.96. What is the ratio of the Unemployed and educated labor force (% of population) of Norway in 2008 to that in 2009?
Keep it short and to the point. 0.97. What is the ratio of the Unemployed and educated labor force (% of population) of Costa Rica in 2008 to that in 2010?
Give a very brief answer. 1.06. What is the ratio of the Unemployed and educated labor force (% of population) in Italy in 2008 to that in 2010?
Give a very brief answer. 0.97. What is the ratio of the Unemployed and educated labor force (% of population) of Jordan in 2008 to that in 2010?
Your answer should be compact. 0.88. What is the ratio of the Unemployed and educated labor force (% of population) in Norway in 2008 to that in 2010?
Give a very brief answer. 0.94. What is the ratio of the Unemployed and educated labor force (% of population) of Costa Rica in 2008 to that in 2011?
Provide a short and direct response. 0.9. What is the ratio of the Unemployed and educated labor force (% of population) of Jordan in 2008 to that in 2011?
Offer a very short reply. 0.88. What is the ratio of the Unemployed and educated labor force (% of population) of Norway in 2008 to that in 2011?
Keep it short and to the point. 0.93. What is the ratio of the Unemployed and educated labor force (% of population) in Costa Rica in 2008 to that in 2012?
Ensure brevity in your answer.  0.92. What is the ratio of the Unemployed and educated labor force (% of population) of Jordan in 2008 to that in 2012?
Your answer should be compact. 0.82. What is the ratio of the Unemployed and educated labor force (% of population) in Norway in 2008 to that in 2012?
Your answer should be compact. 0.83. What is the ratio of the Unemployed and educated labor force (% of population) in Costa Rica in 2009 to that in 2010?
Provide a short and direct response. 0.78. What is the ratio of the Unemployed and educated labor force (% of population) in Italy in 2009 to that in 2010?
Make the answer very short. 1.01. What is the ratio of the Unemployed and educated labor force (% of population) of Jordan in 2009 to that in 2010?
Ensure brevity in your answer.  0.9. What is the ratio of the Unemployed and educated labor force (% of population) in Norway in 2009 to that in 2010?
Keep it short and to the point. 0.96. What is the ratio of the Unemployed and educated labor force (% of population) of Costa Rica in 2009 to that in 2011?
Keep it short and to the point. 0.67. What is the ratio of the Unemployed and educated labor force (% of population) in Italy in 2009 to that in 2011?
Give a very brief answer. 1.05. What is the ratio of the Unemployed and educated labor force (% of population) of Jordan in 2009 to that in 2011?
Your response must be concise. 0.89. What is the ratio of the Unemployed and educated labor force (% of population) in Norway in 2009 to that in 2011?
Provide a succinct answer. 0.95. What is the ratio of the Unemployed and educated labor force (% of population) in Costa Rica in 2009 to that in 2012?
Provide a succinct answer. 0.68. What is the ratio of the Unemployed and educated labor force (% of population) in Italy in 2009 to that in 2012?
Make the answer very short. 1.04. What is the ratio of the Unemployed and educated labor force (% of population) in Jordan in 2009 to that in 2012?
Your response must be concise. 0.83. What is the ratio of the Unemployed and educated labor force (% of population) of Norway in 2009 to that in 2012?
Provide a succinct answer. 0.85. What is the ratio of the Unemployed and educated labor force (% of population) in Costa Rica in 2010 to that in 2011?
Offer a terse response. 0.85. What is the ratio of the Unemployed and educated labor force (% of population) in Italy in 2010 to that in 2011?
Your answer should be compact. 1.04. What is the ratio of the Unemployed and educated labor force (% of population) in Norway in 2010 to that in 2011?
Give a very brief answer. 0.99. What is the ratio of the Unemployed and educated labor force (% of population) of Costa Rica in 2010 to that in 2012?
Make the answer very short. 0.86. What is the ratio of the Unemployed and educated labor force (% of population) of Italy in 2010 to that in 2012?
Offer a terse response. 1.04. What is the ratio of the Unemployed and educated labor force (% of population) of Jordan in 2010 to that in 2012?
Make the answer very short. 0.93. What is the ratio of the Unemployed and educated labor force (% of population) of Norway in 2010 to that in 2012?
Provide a short and direct response. 0.89. What is the ratio of the Unemployed and educated labor force (% of population) in Costa Rica in 2011 to that in 2012?
Make the answer very short. 1.01. What is the ratio of the Unemployed and educated labor force (% of population) of Italy in 2011 to that in 2012?
Keep it short and to the point. 0.99. What is the ratio of the Unemployed and educated labor force (% of population) of Jordan in 2011 to that in 2012?
Offer a very short reply. 0.93. What is the ratio of the Unemployed and educated labor force (% of population) of Norway in 2011 to that in 2012?
Your answer should be compact. 0.9. What is the difference between the highest and the second highest Unemployed and educated labor force (% of population) of Italy?
Your answer should be very brief. 0.1. What is the difference between the highest and the lowest Unemployed and educated labor force (% of population) of Italy?
Your answer should be compact. 3.1. What is the difference between the highest and the lowest Unemployed and educated labor force (% of population) in Jordan?
Your response must be concise. 18.8. What is the difference between the highest and the lowest Unemployed and educated labor force (% of population) in Norway?
Provide a succinct answer. 6.5. 